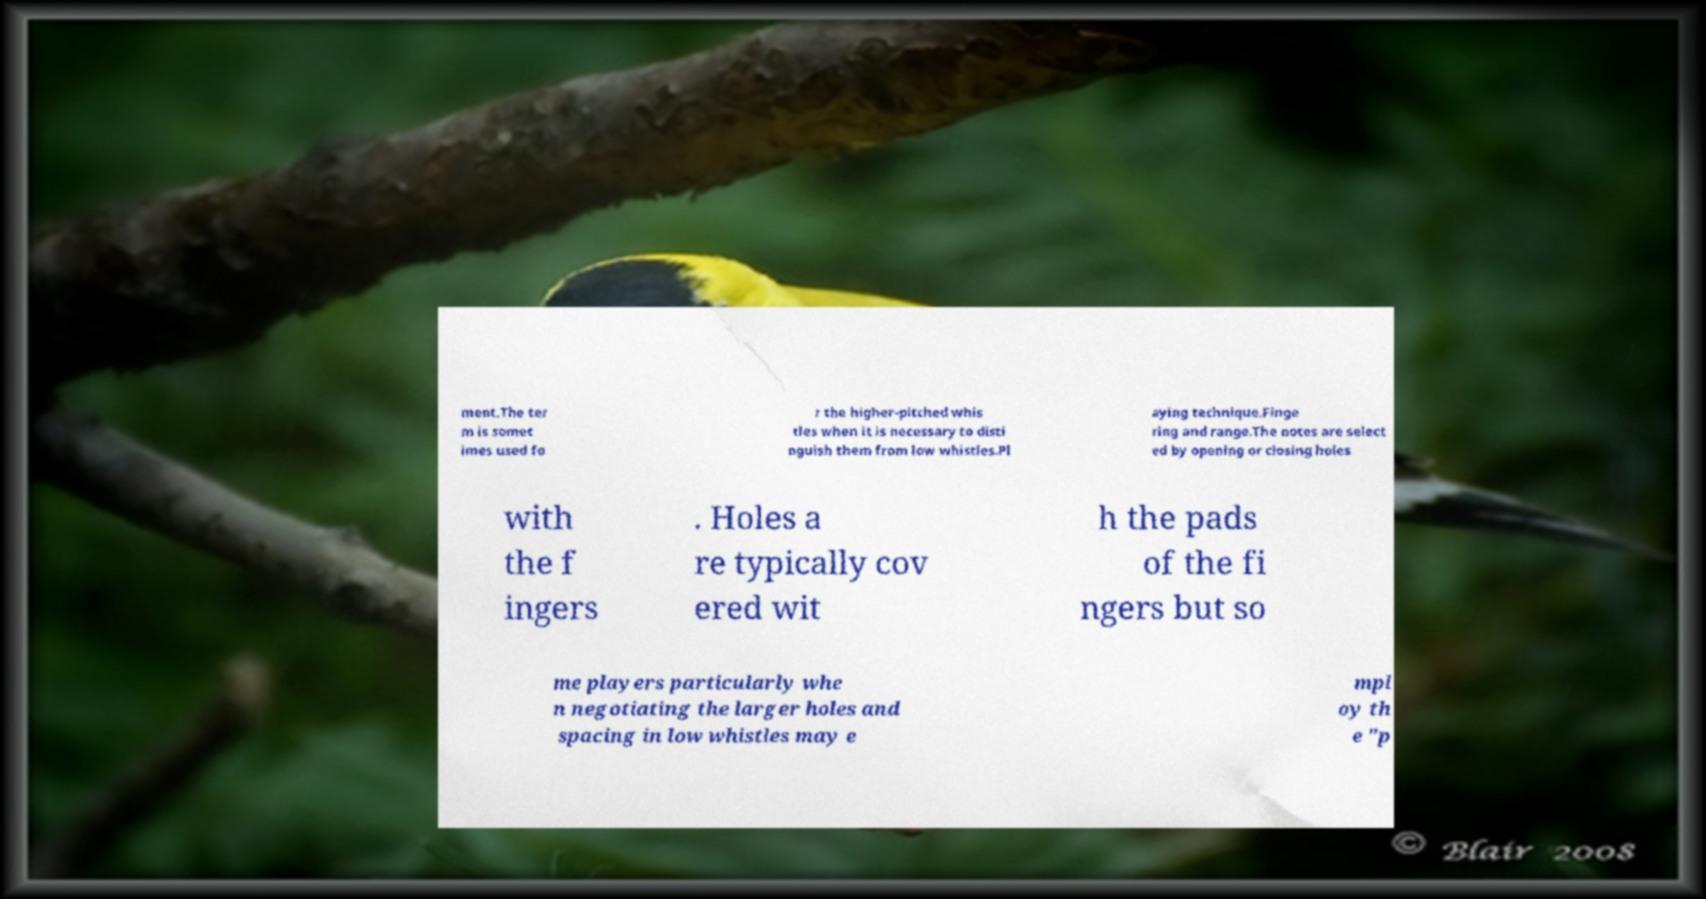I need the written content from this picture converted into text. Can you do that? ment.The ter m is somet imes used fo r the higher-pitched whis tles when it is necessary to disti nguish them from low whistles.Pl aying technique.Finge ring and range.The notes are select ed by opening or closing holes with the f ingers . Holes a re typically cov ered wit h the pads of the fi ngers but so me players particularly whe n negotiating the larger holes and spacing in low whistles may e mpl oy th e "p 